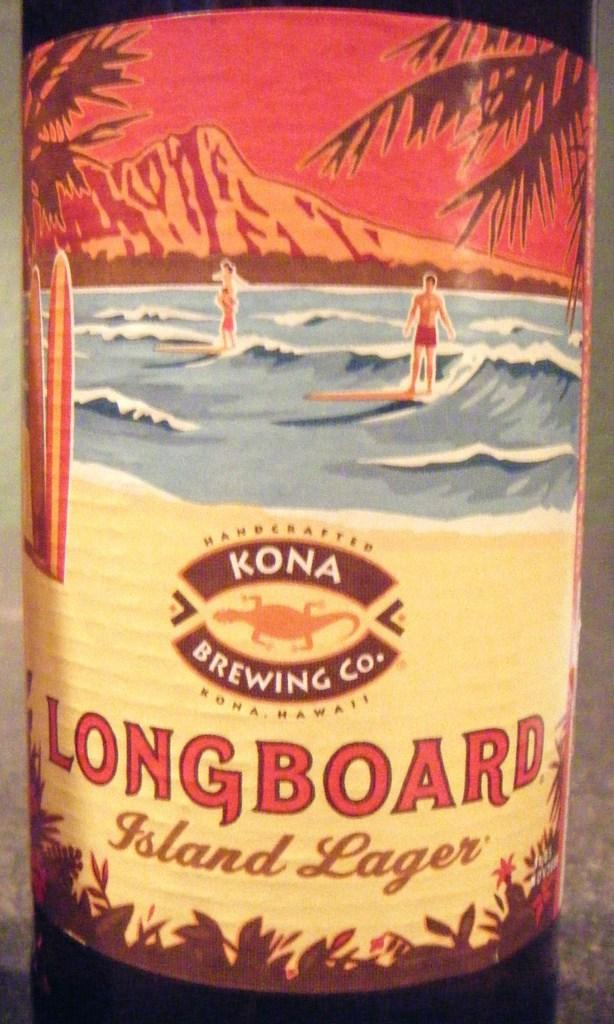Provide a one-sentence caption for the provided image. Bottle of Longboard by Kona Brewing Company showing a man surfing on the label. 